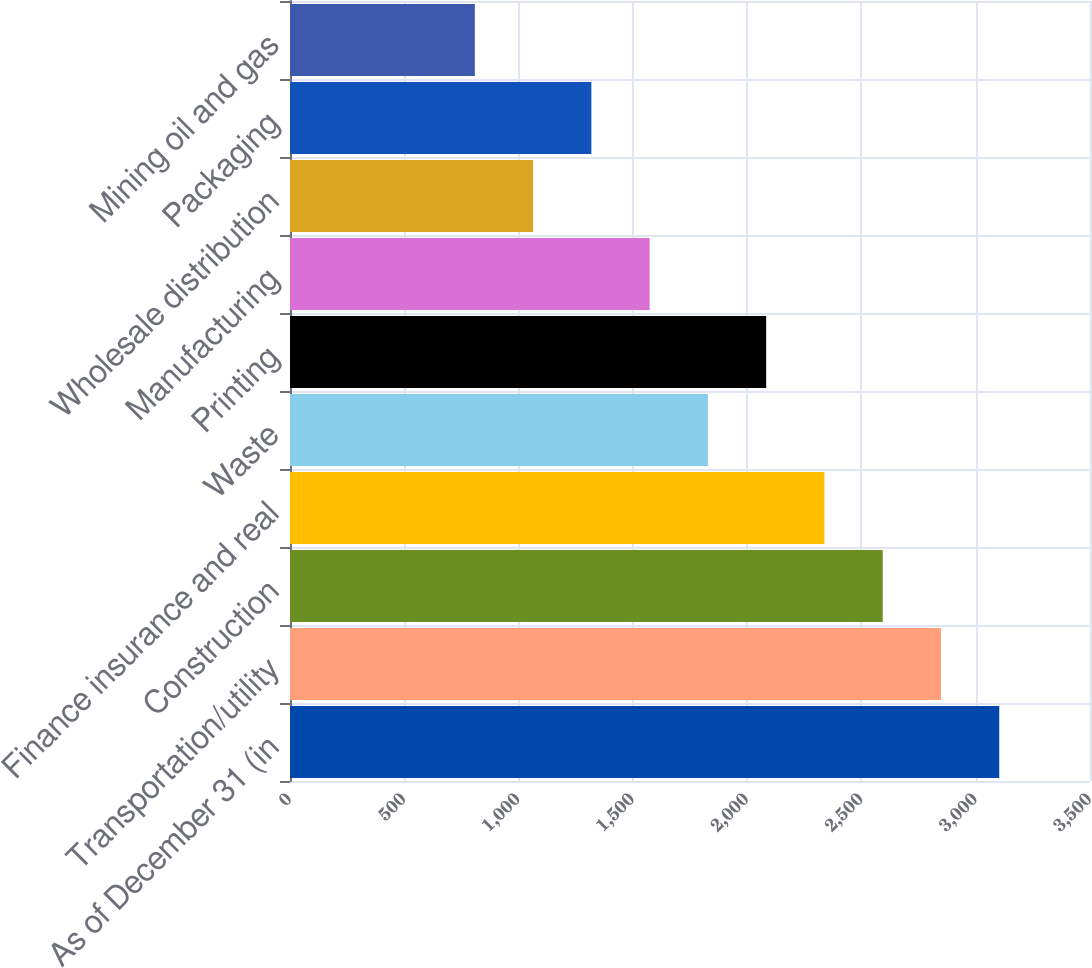<chart> <loc_0><loc_0><loc_500><loc_500><bar_chart><fcel>As of December 31 (in<fcel>Transportation/utility<fcel>Construction<fcel>Finance insurance and real<fcel>Waste<fcel>Printing<fcel>Manufacturing<fcel>Wholesale distribution<fcel>Packaging<fcel>Mining oil and gas<nl><fcel>3102.96<fcel>2848.03<fcel>2593.1<fcel>2338.17<fcel>1828.31<fcel>2083.24<fcel>1573.38<fcel>1063.52<fcel>1318.45<fcel>808.59<nl></chart> 